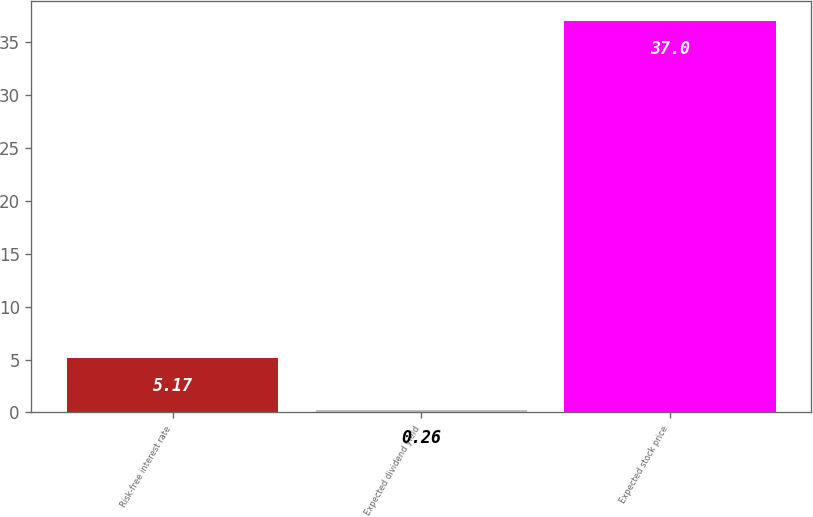Convert chart to OTSL. <chart><loc_0><loc_0><loc_500><loc_500><bar_chart><fcel>Risk-free interest rate<fcel>Expected dividend yield<fcel>Expected stock price<nl><fcel>5.17<fcel>0.26<fcel>37<nl></chart> 